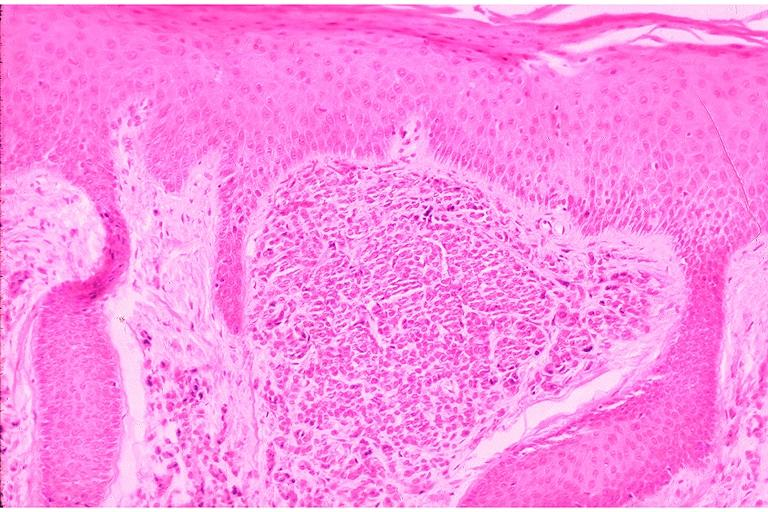s matting history of this case present?
Answer the question using a single word or phrase. No 